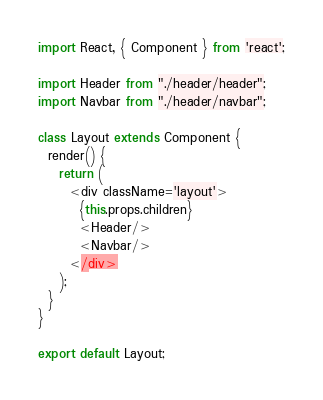Convert code to text. <code><loc_0><loc_0><loc_500><loc_500><_JavaScript_>import React, { Component } from 'react';

import Header from "./header/header";
import Navbar from "./header/navbar";

class Layout extends Component {
  render() {
    return (
      <div className='layout'>
        {this.props.children}
        <Header/>
        <Navbar/>
      </div>
    );
  }
}

export default Layout;
</code> 